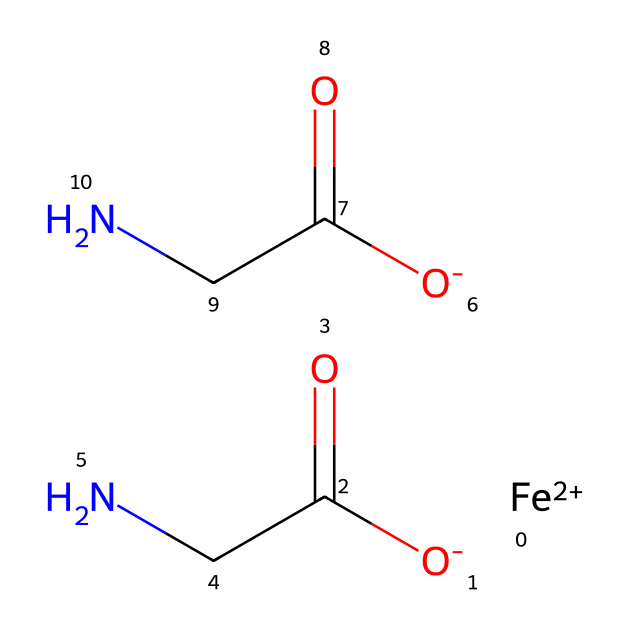What is the central metal in this compound? The SMILES representation indicates the presence of “[Fe+2]”, which signifies the iron ion as the central metal atom.
Answer: iron How many nitrogen atoms are present in the structure? Analyzing the SMILES, there are two occurrences of "N" in the side chains, meaning there are two nitrogen atoms in the compound.
Answer: two What is the charge of the iron in this chelate? The notation “[Fe+2]” clearly indicates a +2 charge on the iron atom, signifying that it is in a divalent state.
Answer: +2 Which functional groups are present in this chelate? Looking at the structure, the fragments “C(=O)CN” suggest the presence of amide functional groups due to "C(=O)" indicating a carbonyl and "CN" indicating the attachment to a nitrogen.
Answer: amide How many oxygen atoms are included in the entire structure? The SMILES shows two “O” atoms in "O-" preceding the carbonyl groups, which counts to a total of two oxygen atoms in the entire chelate structure.
Answer: two Is this compound an example of an organometallic complex? The presence of a metal (in this case, iron) bonded to organic ligands (glycinate) qualifies this compound as an organometallic complex, as it features both metal and non-metal components.
Answer: yes 